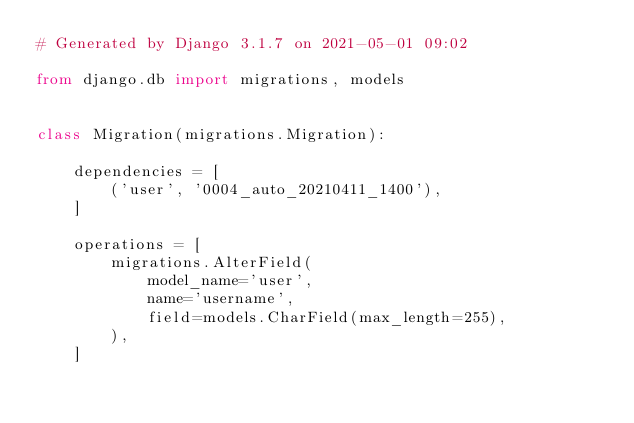Convert code to text. <code><loc_0><loc_0><loc_500><loc_500><_Python_># Generated by Django 3.1.7 on 2021-05-01 09:02

from django.db import migrations, models


class Migration(migrations.Migration):

    dependencies = [
        ('user', '0004_auto_20210411_1400'),
    ]

    operations = [
        migrations.AlterField(
            model_name='user',
            name='username',
            field=models.CharField(max_length=255),
        ),
    ]
</code> 